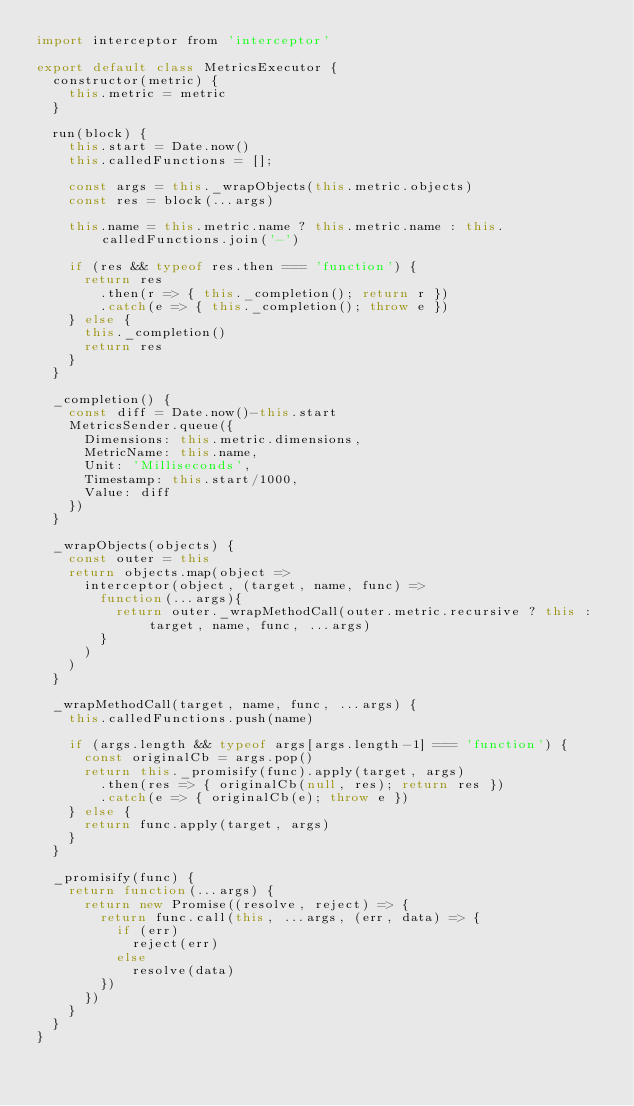<code> <loc_0><loc_0><loc_500><loc_500><_JavaScript_>import interceptor from 'interceptor'

export default class MetricsExecutor {
  constructor(metric) {
    this.metric = metric
  }

  run(block) {
    this.start = Date.now()
    this.calledFunctions = [];

    const args = this._wrapObjects(this.metric.objects)
    const res = block(...args)

    this.name = this.metric.name ? this.metric.name : this.calledFunctions.join('-')

    if (res && typeof res.then === 'function') {
      return res
        .then(r => { this._completion(); return r })
        .catch(e => { this._completion(); throw e })
    } else {
      this._completion()
      return res
    }
  }

  _completion() {
    const diff = Date.now()-this.start
    MetricsSender.queue({
      Dimensions: this.metric.dimensions,
      MetricName: this.name,
      Unit: 'Milliseconds',
      Timestamp: this.start/1000,
      Value: diff
    })
  }

  _wrapObjects(objects) {
    const outer = this
    return objects.map(object =>
      interceptor(object, (target, name, func) =>
        function(...args){
          return outer._wrapMethodCall(outer.metric.recursive ? this : target, name, func, ...args)
        }
      )
    )
  }

  _wrapMethodCall(target, name, func, ...args) {
    this.calledFunctions.push(name)

    if (args.length && typeof args[args.length-1] === 'function') {
      const originalCb = args.pop()
      return this._promisify(func).apply(target, args)
        .then(res => { originalCb(null, res); return res })
        .catch(e => { originalCb(e); throw e })
    } else {
      return func.apply(target, args)
    }
  }

  _promisify(func) {
    return function(...args) {
      return new Promise((resolve, reject) => {
        return func.call(this, ...args, (err, data) => {
          if (err)
            reject(err)
          else
            resolve(data)
        })
      })
    }
  }
}
</code> 